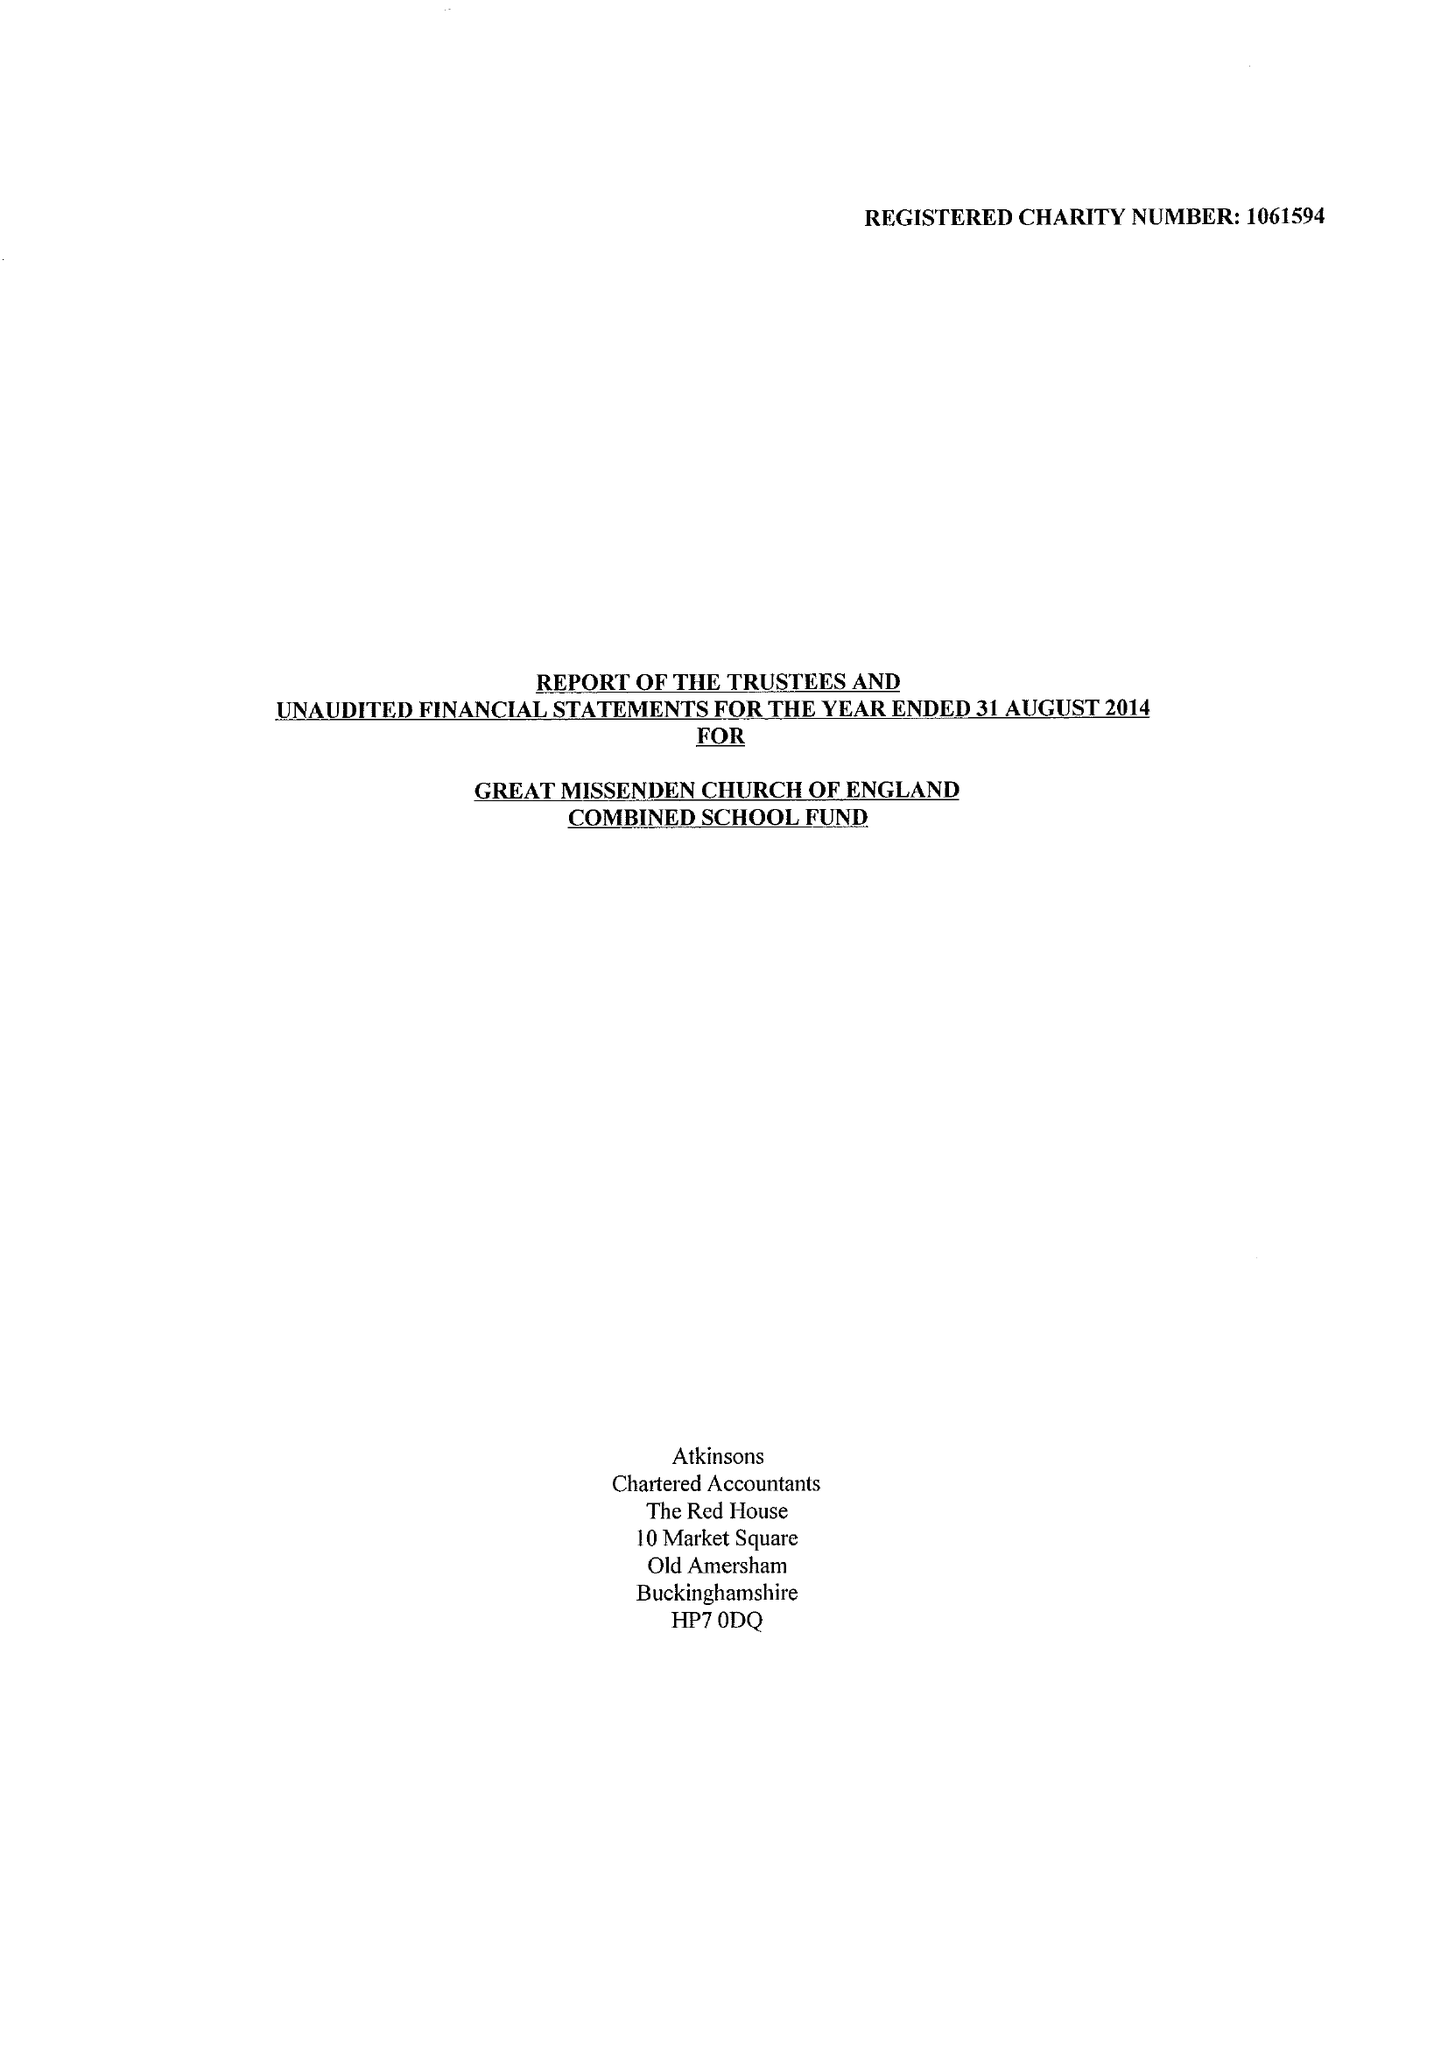What is the value for the address__street_line?
Answer the question using a single word or phrase. CHURCH STREET 